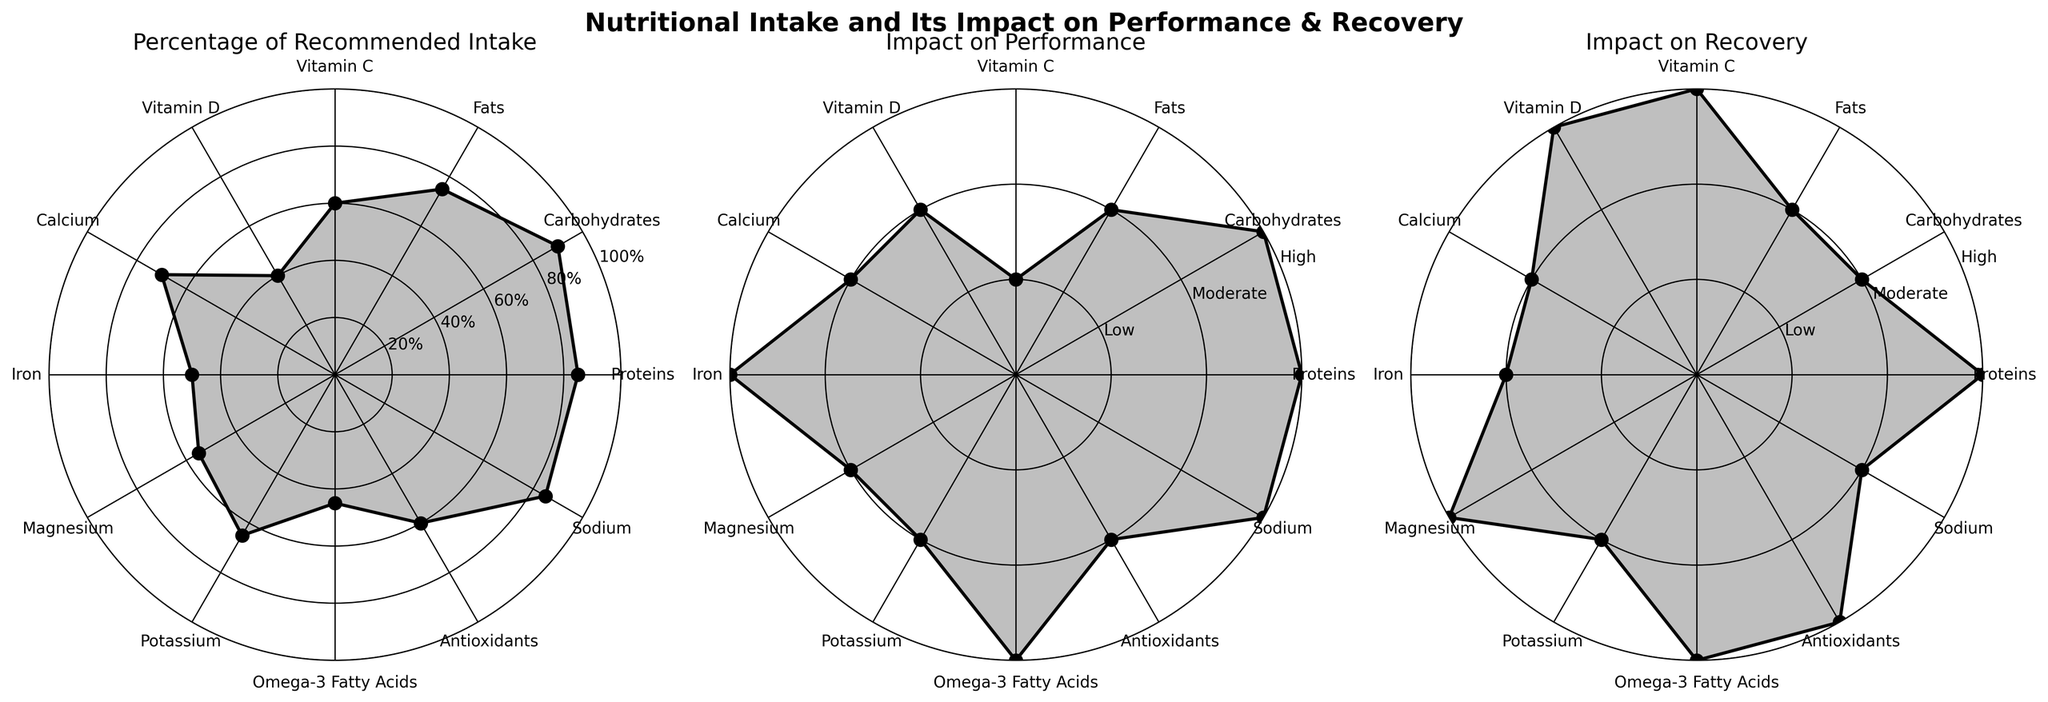What is the title of the figure? The title is located above the subplots and summarizes the entire figure.
Answer: Nutritional Intake and Its Impact on Performance & Recovery How many data points are there for each subplot? Each subplot has a point for each nutrient category plus an extra point to close the polygon.
Answer: 12 Which nutrient has the highest percentage of recommended intake? By looking at the peaks on the "Percentage of Recommended Intake" radar chart, we can compare the values.
Answer: Carbohydrates Which nutrient has the lowest impact on recovery? By looking at the lowest points on the "Impact on Recovery" radar chart, it's possible to determine which nutrients have the lowest impact.
Answer: Vitamin C Among the nutrients, which have both high impact on performance and recovery? Identify nutrients listed as high impact in both the "Impact on Performance" and "Impact on Recovery" radar charts.
Answer: Proteins and Omega-3 Fatty Acids Is the percentage of recommended intake of Iron greater than that of Magnesium? Compare the percentage points of Iron and Magnesium on the "Percentage of Recommended Intake" radar chart.
Answer: Yes How does the impact on performance of Sodium compare to its impact on recovery? Compare the points of Sodium on both the "Impact on Performance" and "Impact on Recovery" radar charts.
Answer: Higher Which category shows more nutrients with 'Moderate' impact on recovery as compared to 'High'? Count and compare the nutrients falling in the 'Moderate' and 'High' impact zones of the "Impact on Recovery" chart.
Answer: Moderate What is the difference in percentage of recommended intake between Proteins and Vitamin D? Subtract the percentage of Vitamin D from the percentage of Proteins on the "Percentage of Recommended Intake" radar chart.
Answer: 45% Considering all nutrients, which has the most equal impact on both performance and recovery? Look for the nutrient whose points are closest to each other on both the "Impact on Performance" and "Impact on Recovery" radar charts.
Answer: Calcium 